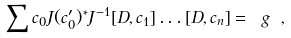<formula> <loc_0><loc_0><loc_500><loc_500>\sum c _ { 0 } J ( c _ { 0 } ^ { \prime } ) ^ { * } J ^ { - 1 } [ D , c _ { 1 } ] \dots [ D , c _ { n } ] = \ g \ ,</formula> 